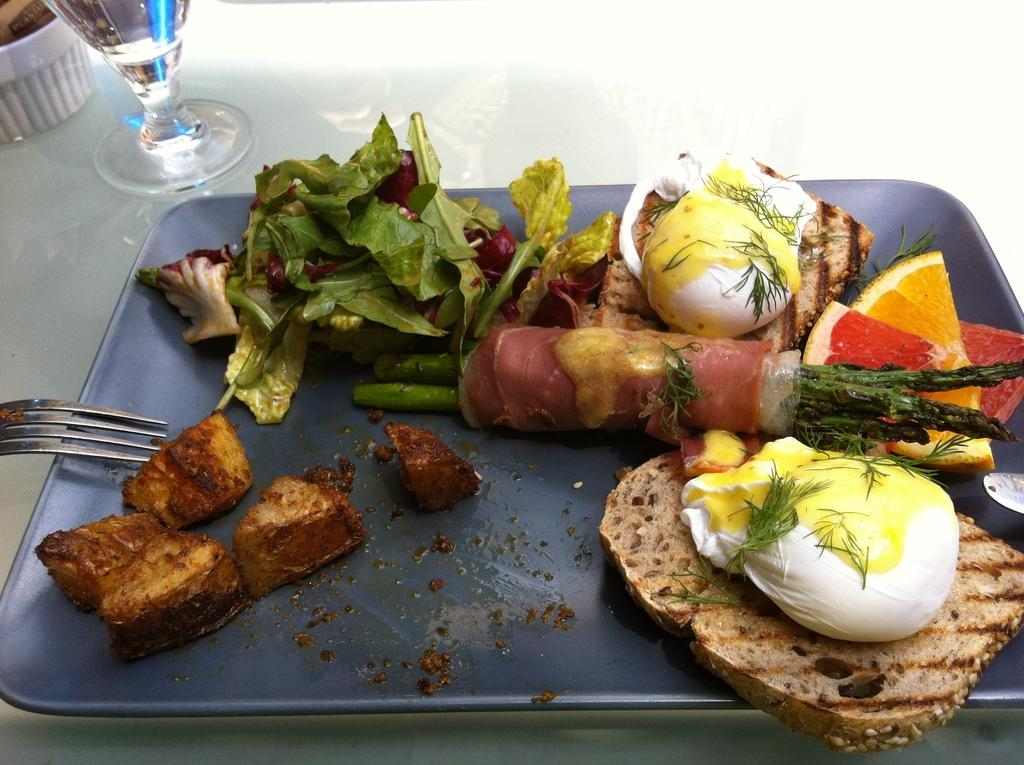What is present in the tray in the image? There are food items in the tray. What utensil can be seen in the image? There is a fork in the image. What type of container is visible in the image? There is a glass in the image. What other objects are present in the image besides the food items, fork, and glass? There are other objects in the image. What color is the surface on which the tray is placed? The tray is on a white color surface. What type of crate is visible in the image? There is no crate present in the image. What mineral is used as a tabletop in the image? The image does not specify the material of the tabletop, but it is not quartz. 